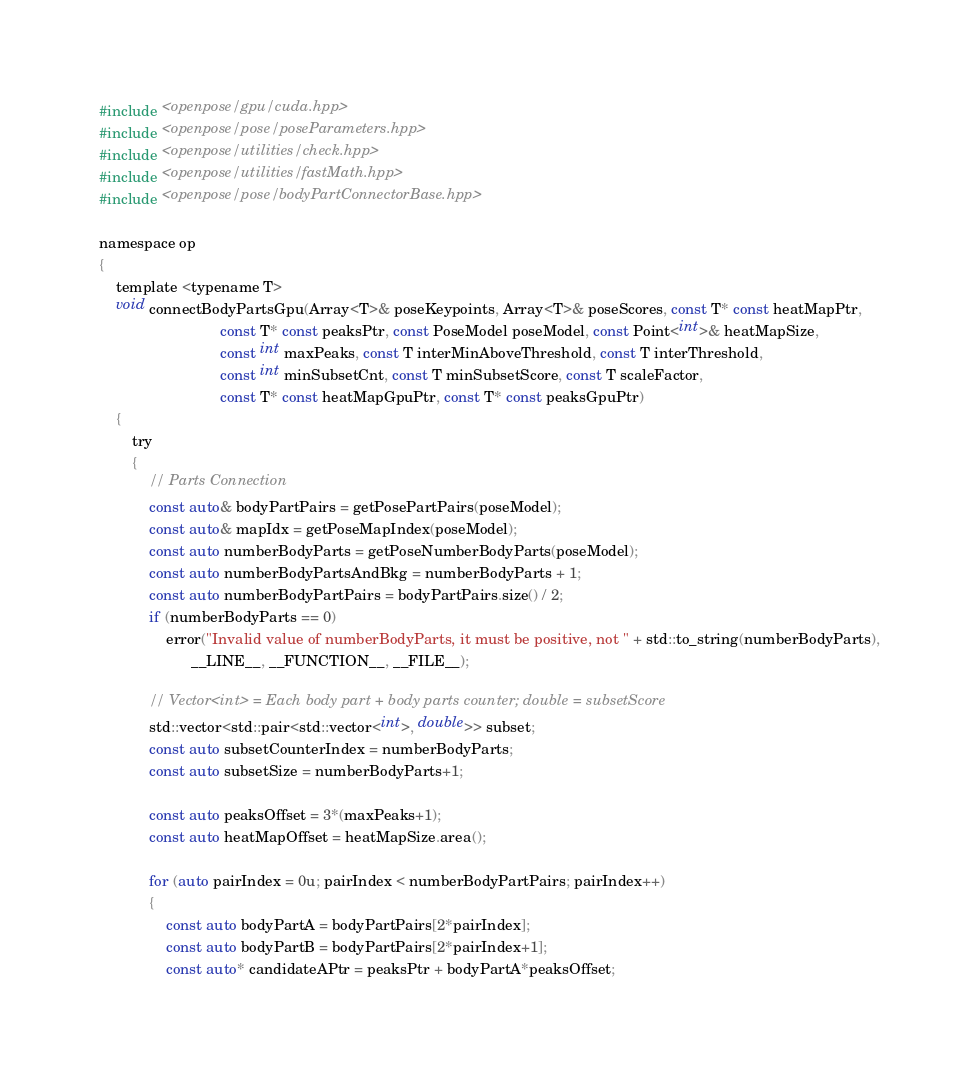Convert code to text. <code><loc_0><loc_0><loc_500><loc_500><_Cuda_>#include <openpose/gpu/cuda.hpp>
#include <openpose/pose/poseParameters.hpp>
#include <openpose/utilities/check.hpp>
#include <openpose/utilities/fastMath.hpp>
#include <openpose/pose/bodyPartConnectorBase.hpp>

namespace op
{
    template <typename T>
    void connectBodyPartsGpu(Array<T>& poseKeypoints, Array<T>& poseScores, const T* const heatMapPtr,
                             const T* const peaksPtr, const PoseModel poseModel, const Point<int>& heatMapSize,
                             const int maxPeaks, const T interMinAboveThreshold, const T interThreshold,
                             const int minSubsetCnt, const T minSubsetScore, const T scaleFactor,
                             const T* const heatMapGpuPtr, const T* const peaksGpuPtr)
    {
        try
        {
            // Parts Connection
            const auto& bodyPartPairs = getPosePartPairs(poseModel);
            const auto& mapIdx = getPoseMapIndex(poseModel);
            const auto numberBodyParts = getPoseNumberBodyParts(poseModel);
            const auto numberBodyPartsAndBkg = numberBodyParts + 1;
            const auto numberBodyPartPairs = bodyPartPairs.size() / 2;
            if (numberBodyParts == 0)
                error("Invalid value of numberBodyParts, it must be positive, not " + std::to_string(numberBodyParts),
                      __LINE__, __FUNCTION__, __FILE__);

            // Vector<int> = Each body part + body parts counter; double = subsetScore
            std::vector<std::pair<std::vector<int>, double>> subset;
            const auto subsetCounterIndex = numberBodyParts;
            const auto subsetSize = numberBodyParts+1;

            const auto peaksOffset = 3*(maxPeaks+1);
            const auto heatMapOffset = heatMapSize.area();

            for (auto pairIndex = 0u; pairIndex < numberBodyPartPairs; pairIndex++)
            {
                const auto bodyPartA = bodyPartPairs[2*pairIndex];
                const auto bodyPartB = bodyPartPairs[2*pairIndex+1];
                const auto* candidateAPtr = peaksPtr + bodyPartA*peaksOffset;</code> 